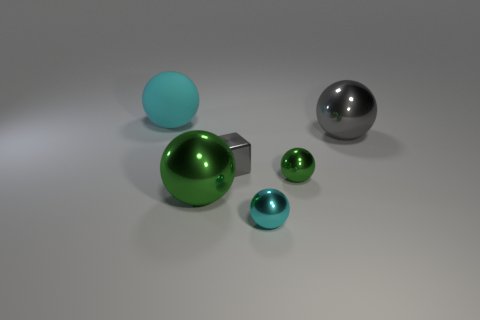What shape is the large object that is both in front of the big cyan rubber object and left of the tiny cyan object?
Your response must be concise. Sphere. There is a gray thing that is on the right side of the thing in front of the big green sphere; is there a big matte thing in front of it?
Keep it short and to the point. No. There is a ball that is both left of the tiny gray metallic thing and in front of the big rubber thing; what size is it?
Your answer should be very brief. Large. What number of cyan things have the same material as the tiny gray thing?
Make the answer very short. 1. How many balls are either yellow objects or small green things?
Offer a terse response. 1. What size is the sphere in front of the green object that is to the left of the cyan ball in front of the cyan rubber sphere?
Make the answer very short. Small. The thing that is behind the gray cube and right of the small cyan metallic thing is what color?
Your answer should be compact. Gray. There is a gray block; is it the same size as the cyan object that is behind the tiny block?
Your response must be concise. No. Are there any other things that are the same shape as the tiny green object?
Your answer should be very brief. Yes. The big rubber object that is the same shape as the cyan metallic thing is what color?
Provide a short and direct response. Cyan. 